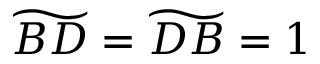<formula> <loc_0><loc_0><loc_500><loc_500>\widetilde { B D } = \widetilde { D B } = 1</formula> 